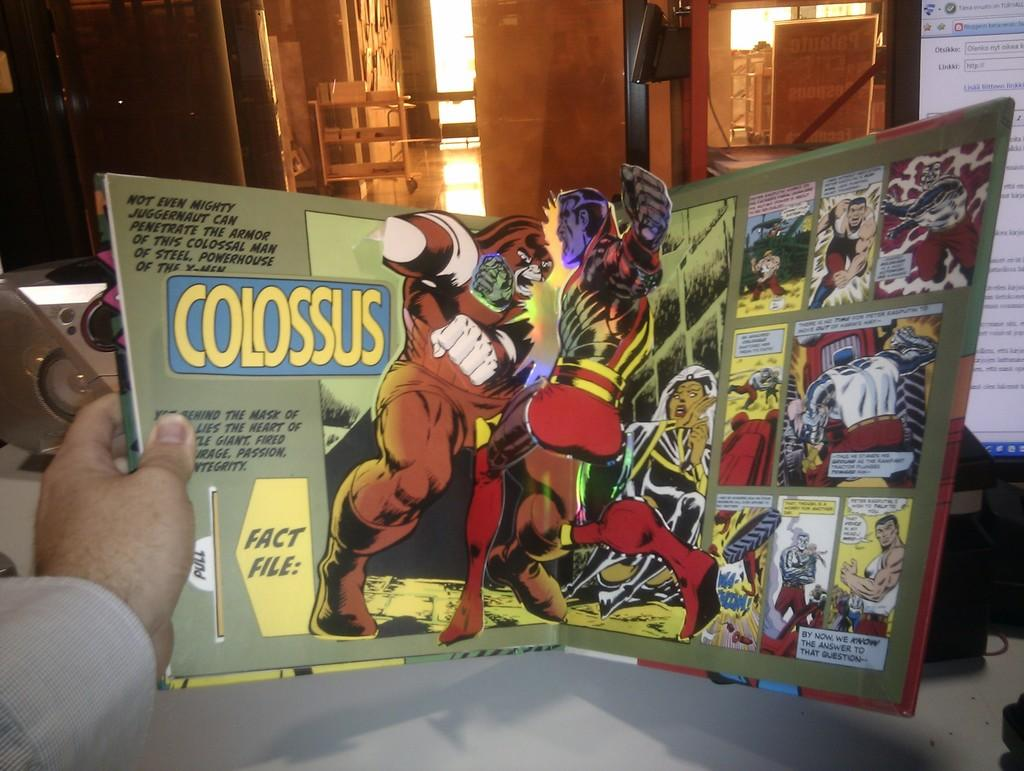<image>
Describe the image concisely. A man holding a comic book called Colossus open a table. 